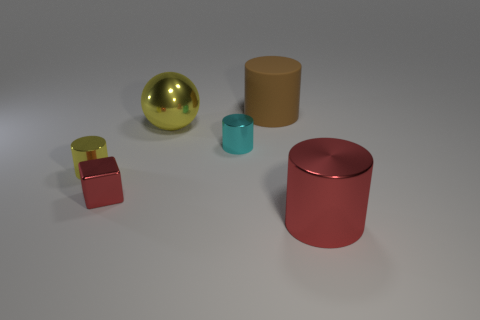Subtract all cyan cylinders. How many cylinders are left? 3 Add 2 brown metallic spheres. How many objects exist? 8 Subtract all yellow cylinders. How many cylinders are left? 3 Subtract all spheres. How many objects are left? 5 Subtract 2 cylinders. How many cylinders are left? 2 Subtract all brown cylinders. Subtract all yellow balls. How many cylinders are left? 3 Subtract all large yellow spheres. Subtract all big balls. How many objects are left? 4 Add 1 tiny yellow metallic things. How many tiny yellow metallic things are left? 2 Add 4 red shiny spheres. How many red shiny spheres exist? 4 Subtract 0 gray spheres. How many objects are left? 6 